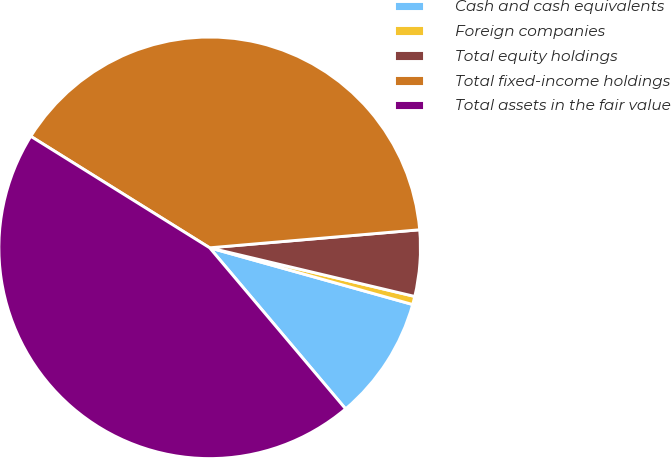<chart> <loc_0><loc_0><loc_500><loc_500><pie_chart><fcel>Cash and cash equivalents<fcel>Foreign companies<fcel>Total equity holdings<fcel>Total fixed-income holdings<fcel>Total assets in the fair value<nl><fcel>9.51%<fcel>0.63%<fcel>5.07%<fcel>39.77%<fcel>45.03%<nl></chart> 